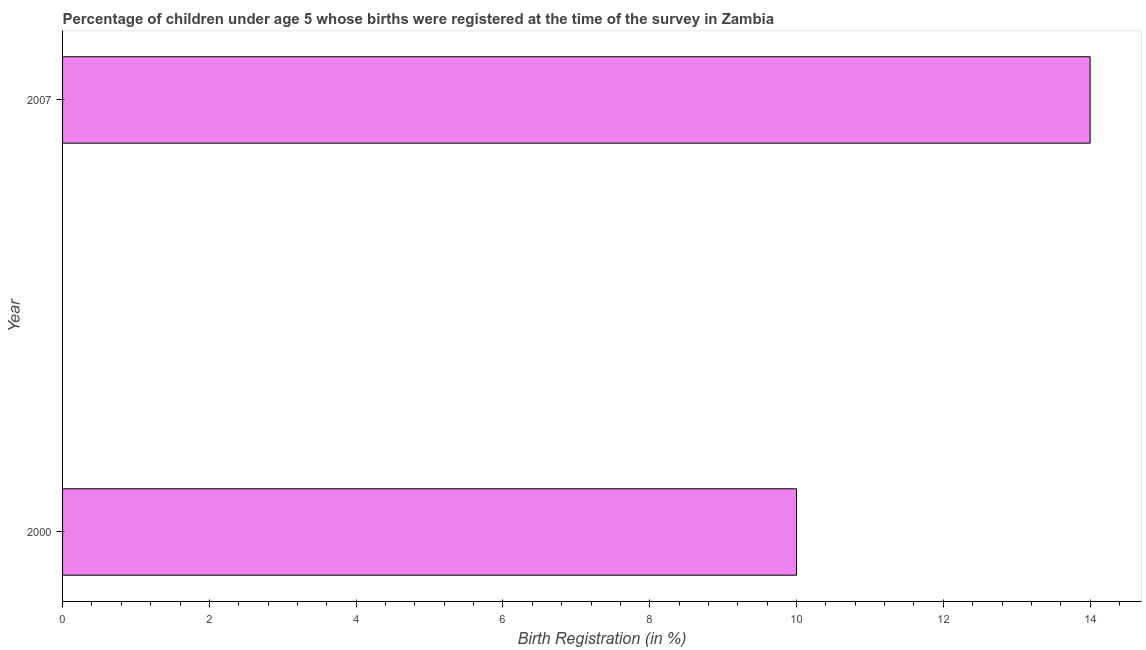Does the graph contain any zero values?
Your answer should be very brief. No. What is the title of the graph?
Keep it short and to the point. Percentage of children under age 5 whose births were registered at the time of the survey in Zambia. What is the label or title of the X-axis?
Keep it short and to the point. Birth Registration (in %). What is the label or title of the Y-axis?
Provide a succinct answer. Year. What is the birth registration in 2007?
Give a very brief answer. 14. Across all years, what is the maximum birth registration?
Provide a succinct answer. 14. In which year was the birth registration minimum?
Make the answer very short. 2000. What is the sum of the birth registration?
Keep it short and to the point. 24. Do a majority of the years between 2000 and 2007 (inclusive) have birth registration greater than 2.4 %?
Give a very brief answer. Yes. What is the ratio of the birth registration in 2000 to that in 2007?
Ensure brevity in your answer.  0.71. Is the birth registration in 2000 less than that in 2007?
Your response must be concise. Yes. In how many years, is the birth registration greater than the average birth registration taken over all years?
Keep it short and to the point. 1. How many bars are there?
Your answer should be very brief. 2. Are all the bars in the graph horizontal?
Give a very brief answer. Yes. How many years are there in the graph?
Your response must be concise. 2. Are the values on the major ticks of X-axis written in scientific E-notation?
Provide a succinct answer. No. What is the ratio of the Birth Registration (in %) in 2000 to that in 2007?
Give a very brief answer. 0.71. 